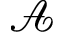Convert formula to latex. <formula><loc_0><loc_0><loc_500><loc_500>\mathcal { A }</formula> 